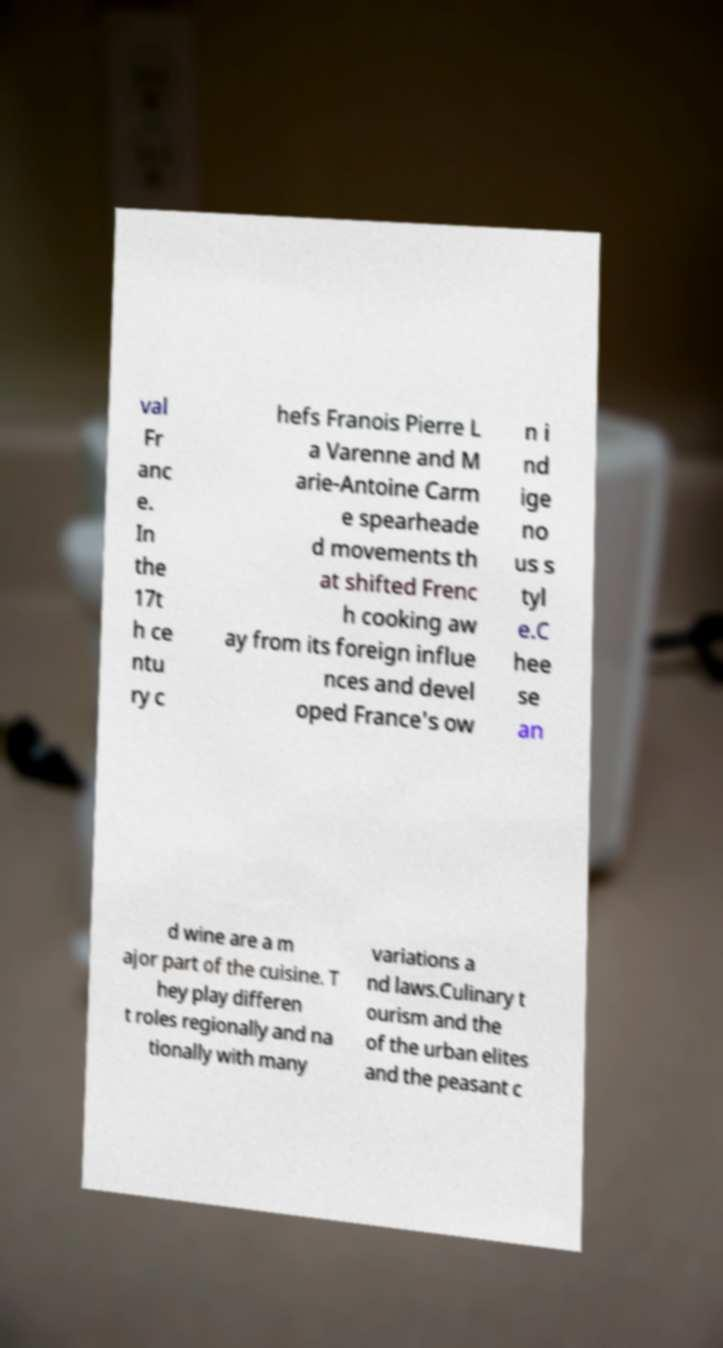Can you read and provide the text displayed in the image?This photo seems to have some interesting text. Can you extract and type it out for me? val Fr anc e. In the 17t h ce ntu ry c hefs Franois Pierre L a Varenne and M arie-Antoine Carm e spearheade d movements th at shifted Frenc h cooking aw ay from its foreign influe nces and devel oped France's ow n i nd ige no us s tyl e.C hee se an d wine are a m ajor part of the cuisine. T hey play differen t roles regionally and na tionally with many variations a nd laws.Culinary t ourism and the of the urban elites and the peasant c 